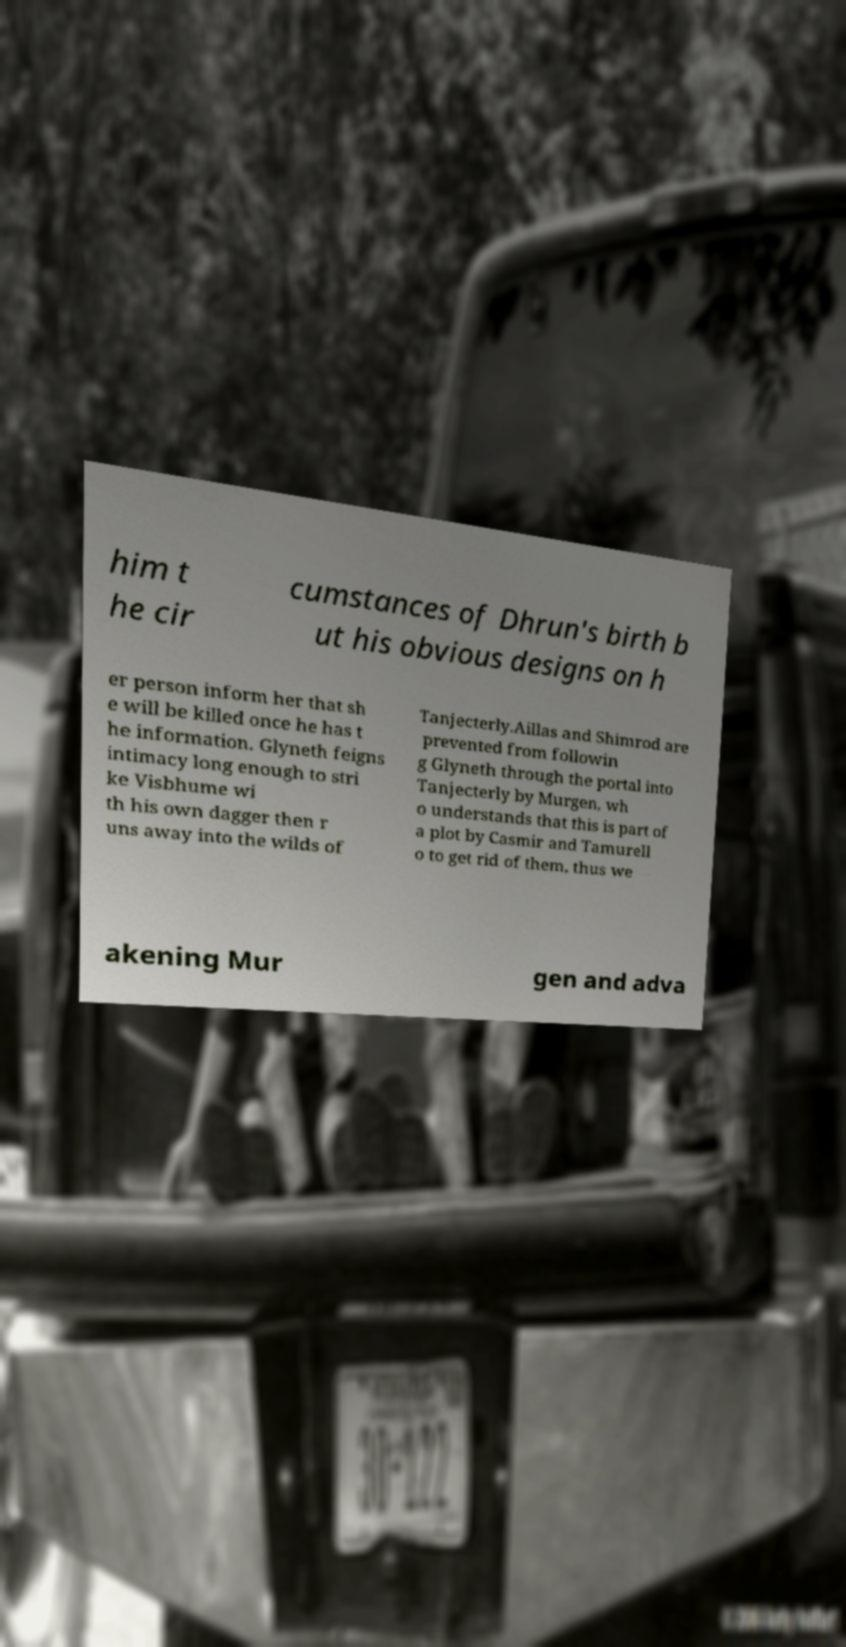Could you assist in decoding the text presented in this image and type it out clearly? him t he cir cumstances of Dhrun's birth b ut his obvious designs on h er person inform her that sh e will be killed once he has t he information. Glyneth feigns intimacy long enough to stri ke Visbhume wi th his own dagger then r uns away into the wilds of Tanjecterly.Aillas and Shimrod are prevented from followin g Glyneth through the portal into Tanjecterly by Murgen, wh o understands that this is part of a plot by Casmir and Tamurell o to get rid of them, thus we akening Mur gen and adva 